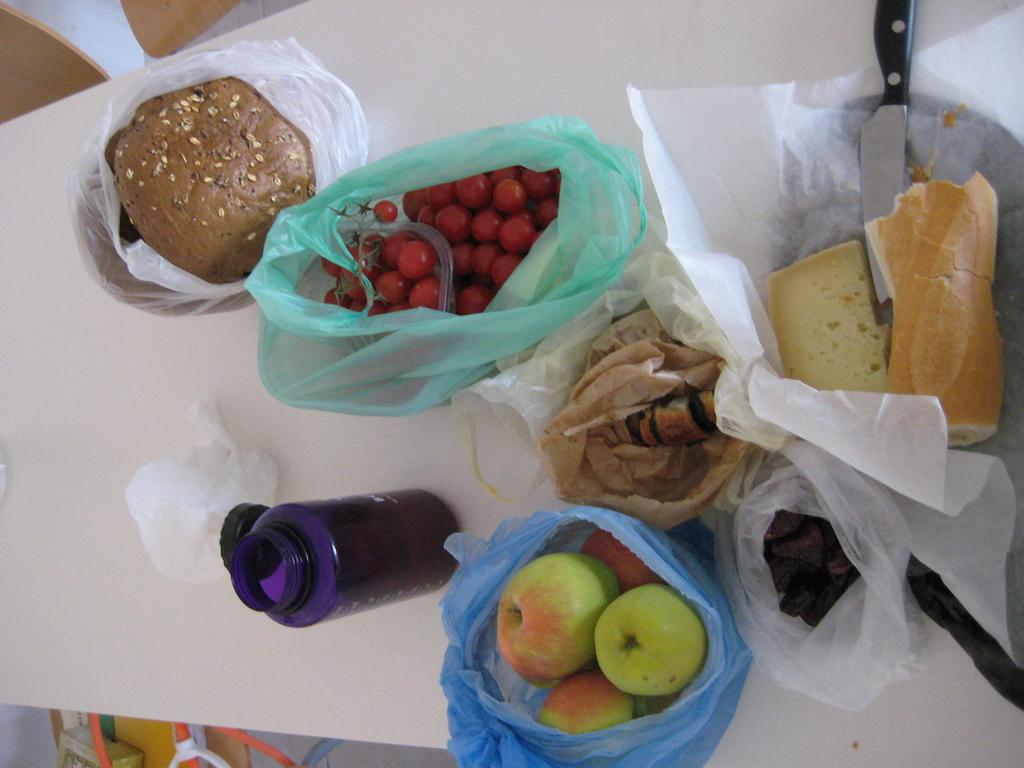What piece of furniture is present in the image? There is a table in the image. What is the condition of the food items on the table? The food items on the table are covered. What utensil is located beside the food items? There is a knife beside the food items. What type of container is beside the food items? There is a bottle beside the food items. What type of payment method is accepted at the table in the image? There is no indication of any payment method in the image, as it only shows a table with covered food items, a knife, and a bottle. 